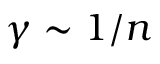<formula> <loc_0><loc_0><loc_500><loc_500>\gamma \sim 1 / n</formula> 